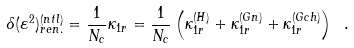<formula> <loc_0><loc_0><loc_500><loc_500>\delta ( { \varepsilon } ^ { 2 } ) _ { r e n . } ^ { ( n t l ) } = \frac { 1 } { N _ { c } } \kappa _ { 1 r } = \frac { 1 } { N _ { c } } \left ( \kappa _ { 1 r } ^ { ( H ) } + \kappa _ { 1 r } ^ { ( G n ) } + \kappa _ { 1 r } ^ { ( G c h ) } \right ) \ .</formula> 